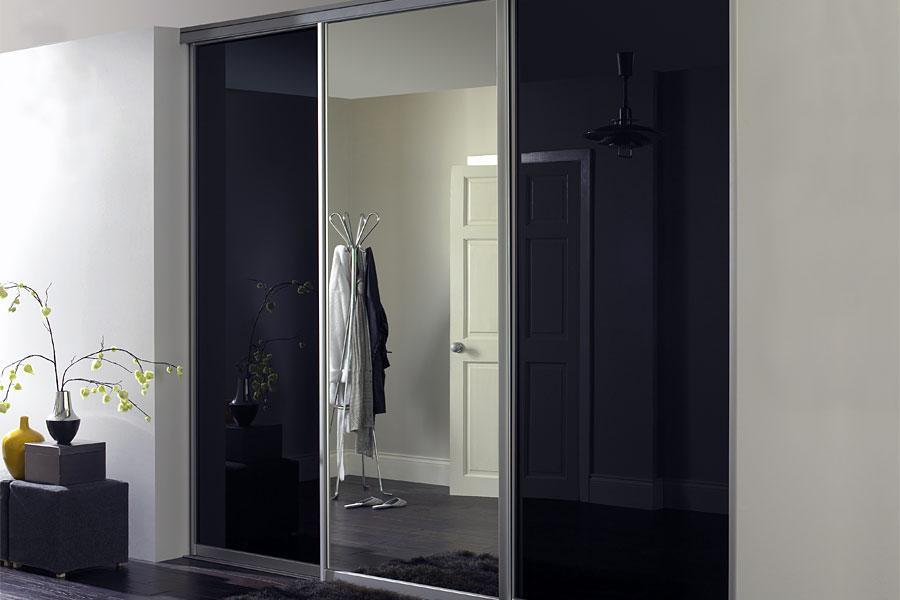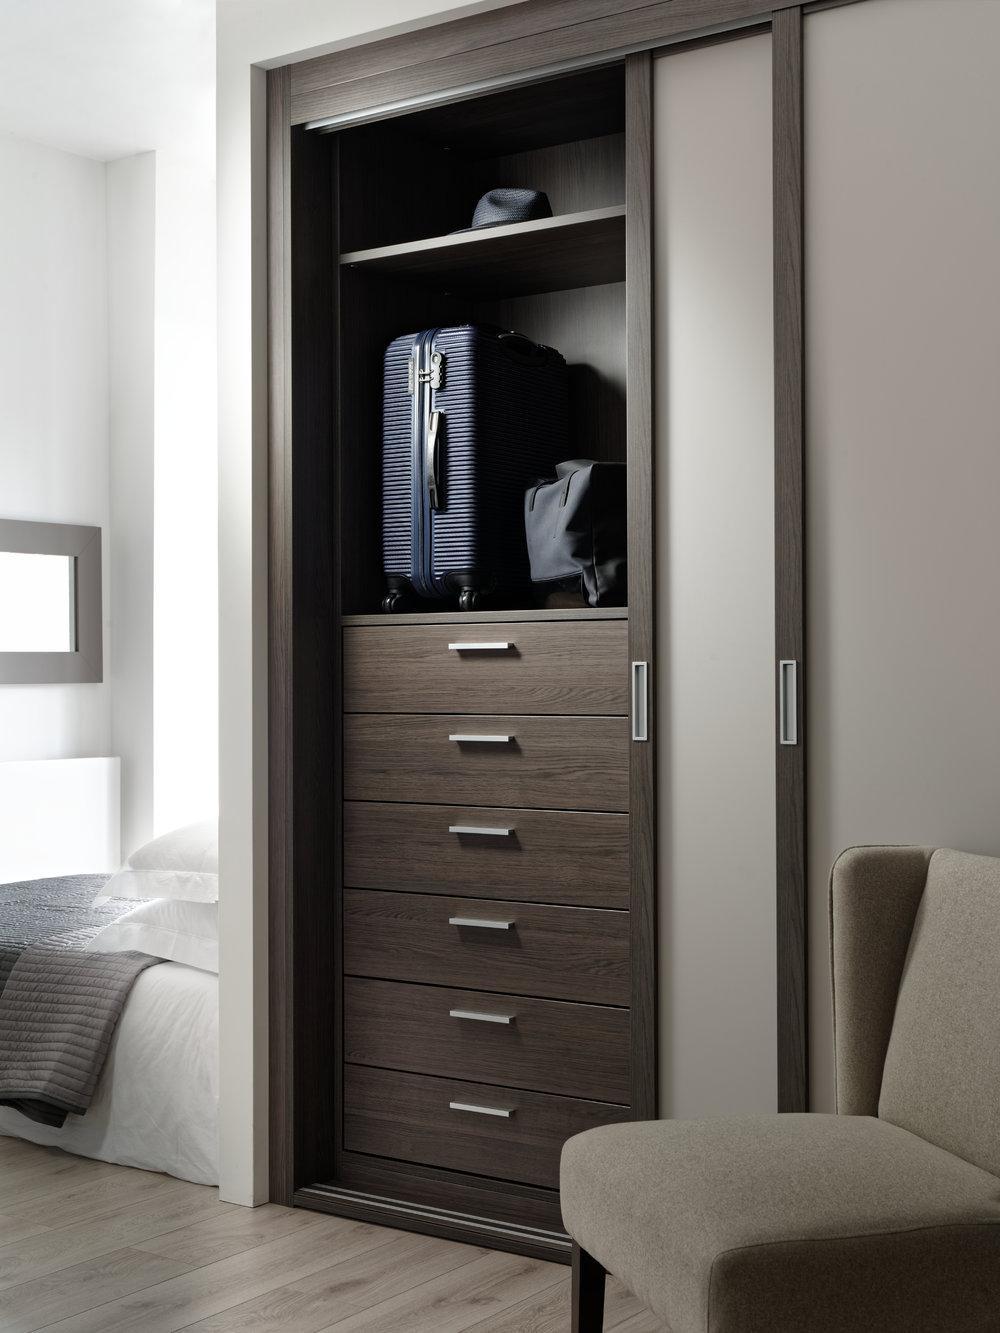The first image is the image on the left, the second image is the image on the right. Examine the images to the left and right. Is the description "Both closets are closed." accurate? Answer yes or no. No. 